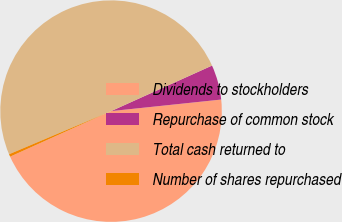Convert chart. <chart><loc_0><loc_0><loc_500><loc_500><pie_chart><fcel>Dividends to stockholders<fcel>Repurchase of common stock<fcel>Total cash returned to<fcel>Number of shares repurchased<nl><fcel>44.92%<fcel>5.08%<fcel>49.62%<fcel>0.38%<nl></chart> 